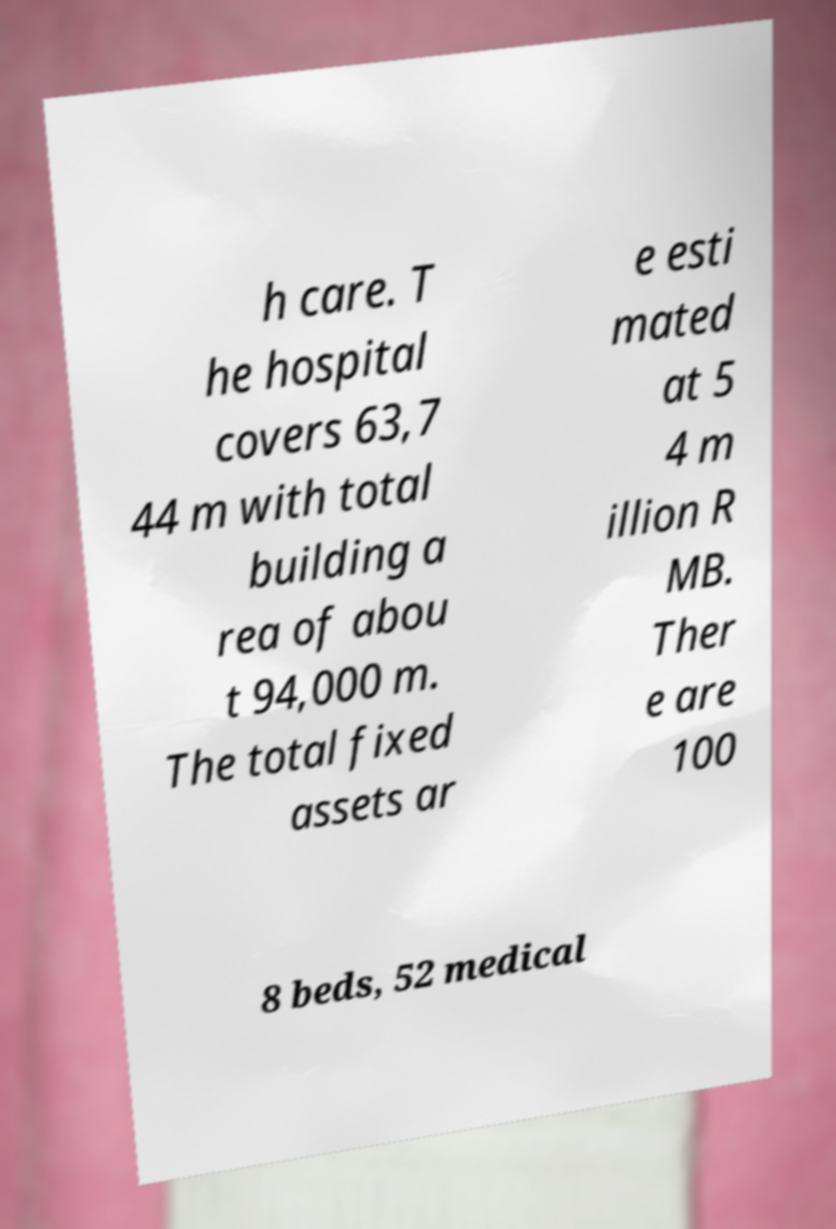For documentation purposes, I need the text within this image transcribed. Could you provide that? h care. T he hospital covers 63,7 44 m with total building a rea of abou t 94,000 m. The total fixed assets ar e esti mated at 5 4 m illion R MB. Ther e are 100 8 beds, 52 medical 